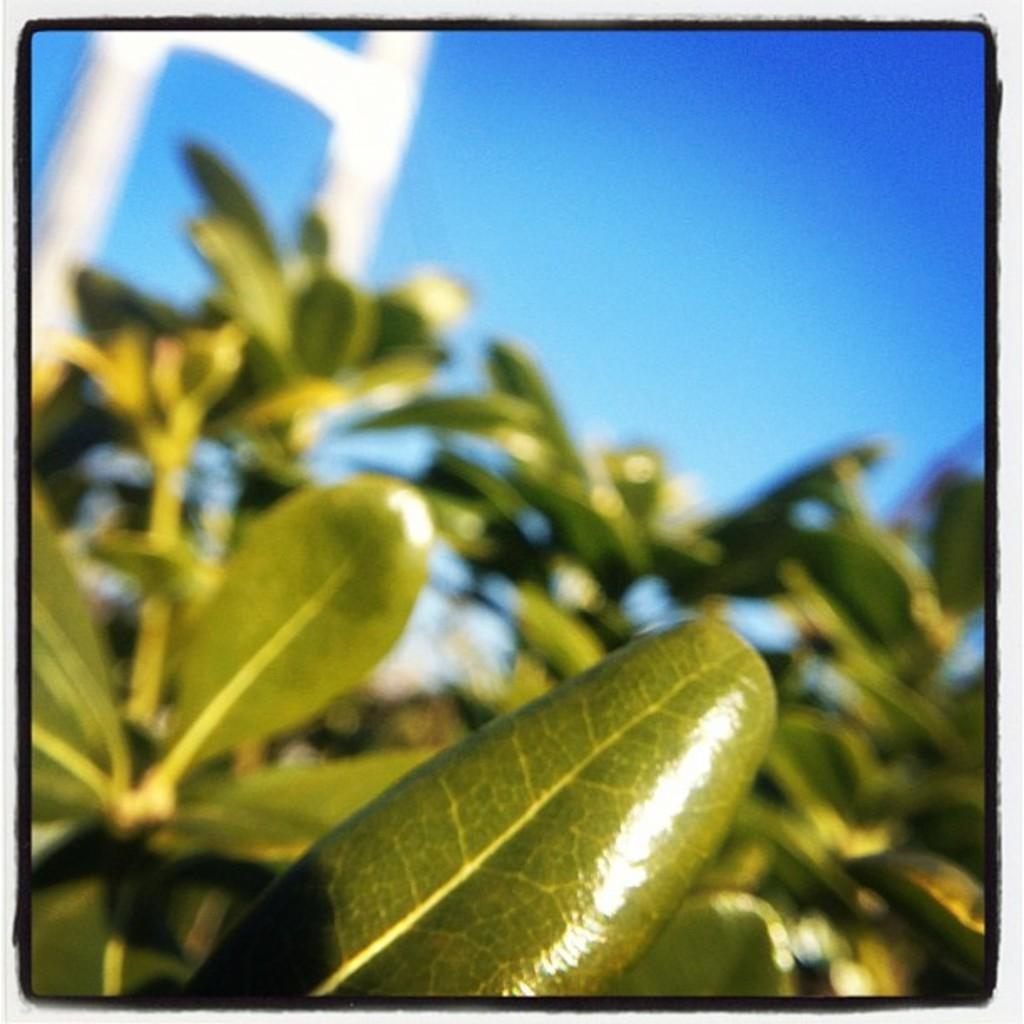What is present at the bottom of the image? There are leaves at the bottom of the image. What can be seen at the top of the image? The sky is visible at the top of the image. What type of rock is being hammered in the image? There is no rock or hammer present in the image; it only features leaves at the bottom and the sky at the top. 